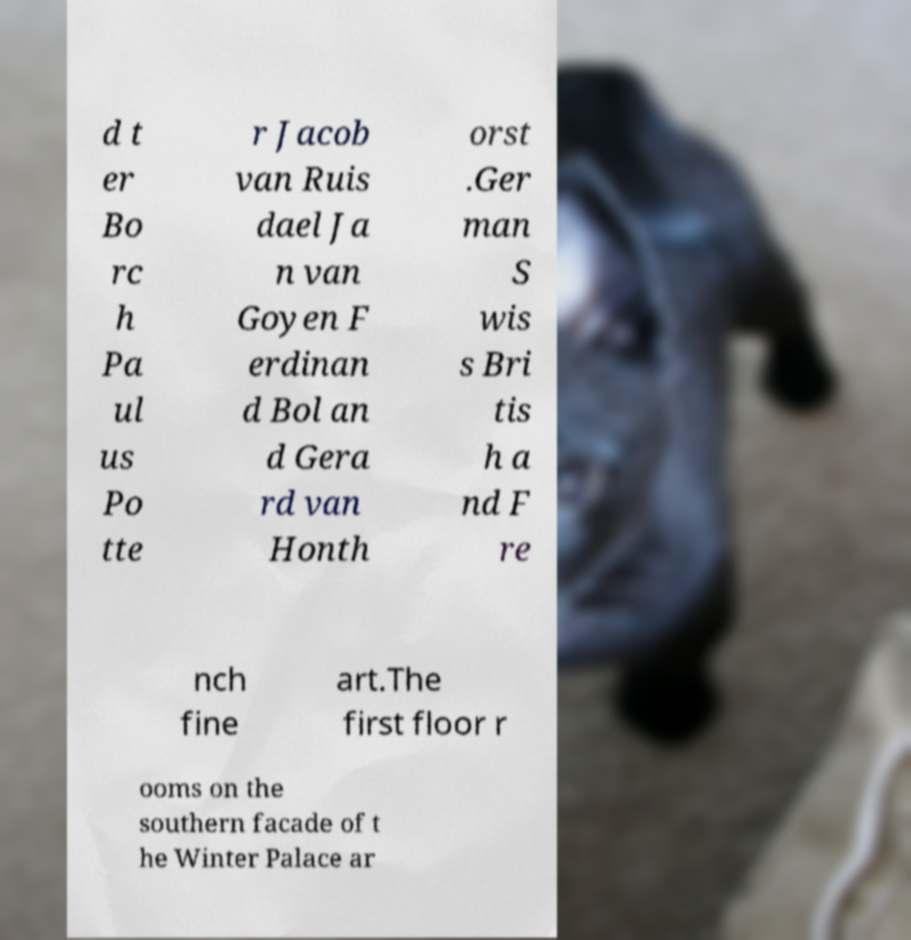Please read and relay the text visible in this image. What does it say? d t er Bo rc h Pa ul us Po tte r Jacob van Ruis dael Ja n van Goyen F erdinan d Bol an d Gera rd van Honth orst .Ger man S wis s Bri tis h a nd F re nch fine art.The first floor r ooms on the southern facade of t he Winter Palace ar 